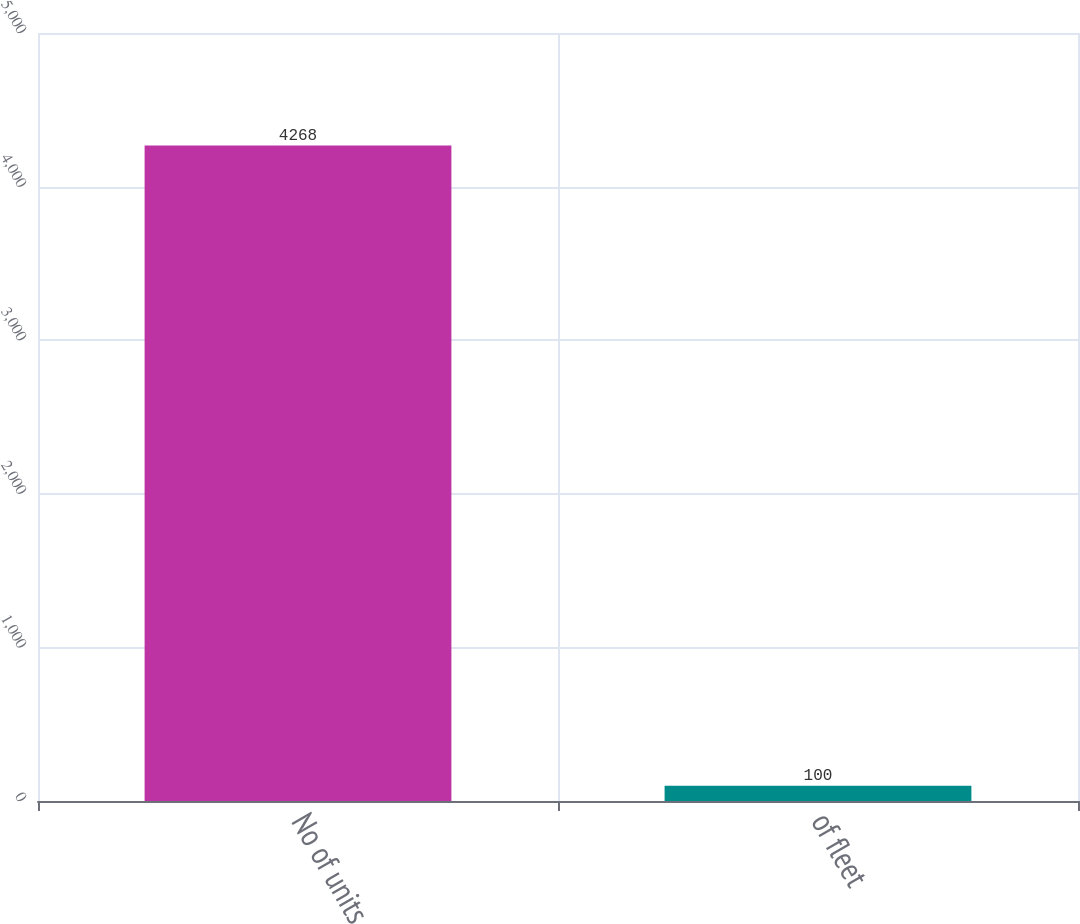Convert chart to OTSL. <chart><loc_0><loc_0><loc_500><loc_500><bar_chart><fcel>No of units<fcel>of fleet<nl><fcel>4268<fcel>100<nl></chart> 